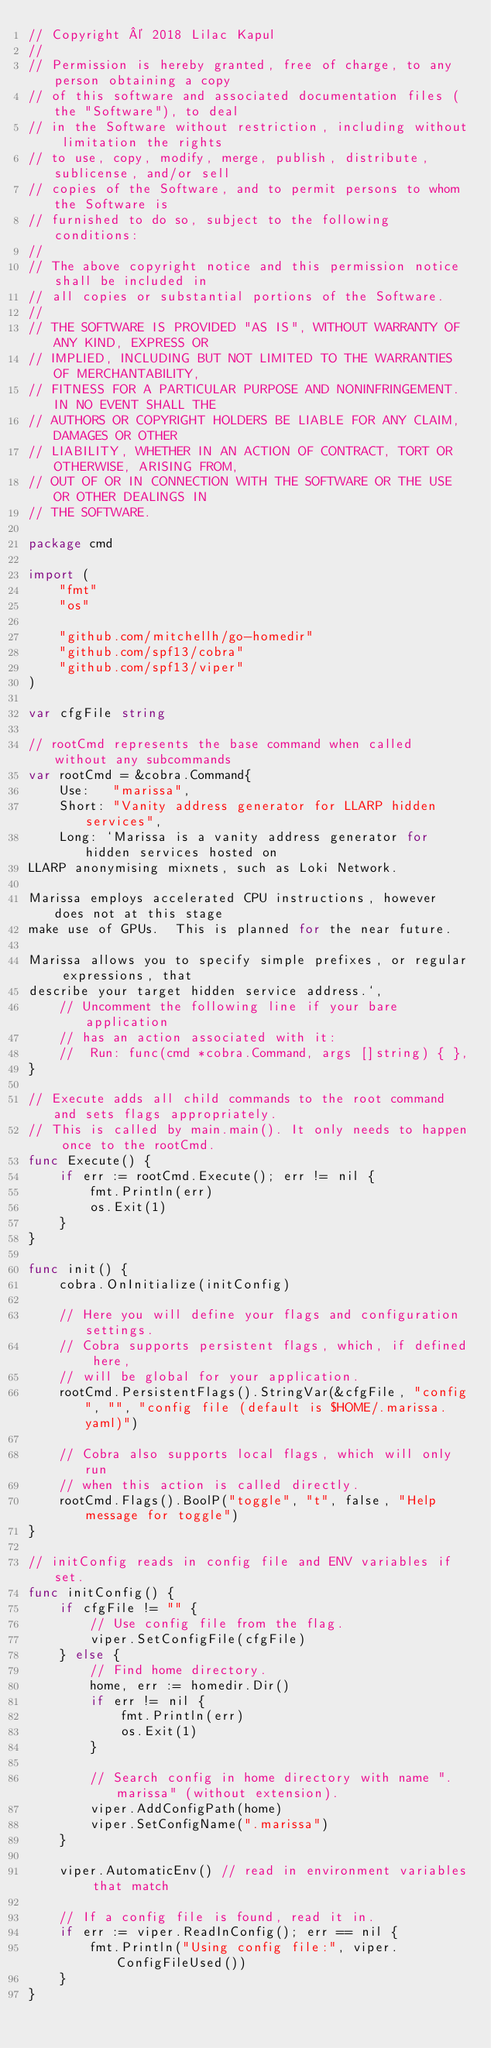<code> <loc_0><loc_0><loc_500><loc_500><_Go_>// Copyright © 2018 Lilac Kapul
//
// Permission is hereby granted, free of charge, to any person obtaining a copy
// of this software and associated documentation files (the "Software"), to deal
// in the Software without restriction, including without limitation the rights
// to use, copy, modify, merge, publish, distribute, sublicense, and/or sell
// copies of the Software, and to permit persons to whom the Software is
// furnished to do so, subject to the following conditions:
//
// The above copyright notice and this permission notice shall be included in
// all copies or substantial portions of the Software.
//
// THE SOFTWARE IS PROVIDED "AS IS", WITHOUT WARRANTY OF ANY KIND, EXPRESS OR
// IMPLIED, INCLUDING BUT NOT LIMITED TO THE WARRANTIES OF MERCHANTABILITY,
// FITNESS FOR A PARTICULAR PURPOSE AND NONINFRINGEMENT. IN NO EVENT SHALL THE
// AUTHORS OR COPYRIGHT HOLDERS BE LIABLE FOR ANY CLAIM, DAMAGES OR OTHER
// LIABILITY, WHETHER IN AN ACTION OF CONTRACT, TORT OR OTHERWISE, ARISING FROM,
// OUT OF OR IN CONNECTION WITH THE SOFTWARE OR THE USE OR OTHER DEALINGS IN
// THE SOFTWARE.

package cmd

import (
	"fmt"
	"os"

	"github.com/mitchellh/go-homedir"
	"github.com/spf13/cobra"
	"github.com/spf13/viper"
)

var cfgFile string

// rootCmd represents the base command when called without any subcommands
var rootCmd = &cobra.Command{
	Use:   "marissa",
	Short: "Vanity address generator for LLARP hidden services",
	Long: `Marissa is a vanity address generator for hidden services hosted on
LLARP anonymising mixnets, such as Loki Network.

Marissa employs accelerated CPU instructions, however does not at this stage
make use of GPUs.  This is planned for the near future.

Marissa allows you to specify simple prefixes, or regular expressions, that
describe your target hidden service address.`,
	// Uncomment the following line if your bare application
	// has an action associated with it:
	// 	Run: func(cmd *cobra.Command, args []string) { },
}

// Execute adds all child commands to the root command and sets flags appropriately.
// This is called by main.main(). It only needs to happen once to the rootCmd.
func Execute() {
	if err := rootCmd.Execute(); err != nil {
		fmt.Println(err)
		os.Exit(1)
	}
}

func init() {
	cobra.OnInitialize(initConfig)

	// Here you will define your flags and configuration settings.
	// Cobra supports persistent flags, which, if defined here,
	// will be global for your application.
	rootCmd.PersistentFlags().StringVar(&cfgFile, "config", "", "config file (default is $HOME/.marissa.yaml)")

	// Cobra also supports local flags, which will only run
	// when this action is called directly.
	rootCmd.Flags().BoolP("toggle", "t", false, "Help message for toggle")
}

// initConfig reads in config file and ENV variables if set.
func initConfig() {
	if cfgFile != "" {
		// Use config file from the flag.
		viper.SetConfigFile(cfgFile)
	} else {
		// Find home directory.
		home, err := homedir.Dir()
		if err != nil {
			fmt.Println(err)
			os.Exit(1)
		}

		// Search config in home directory with name ".marissa" (without extension).
		viper.AddConfigPath(home)
		viper.SetConfigName(".marissa")
	}

	viper.AutomaticEnv() // read in environment variables that match

	// If a config file is found, read it in.
	if err := viper.ReadInConfig(); err == nil {
		fmt.Println("Using config file:", viper.ConfigFileUsed())
	}
}
</code> 